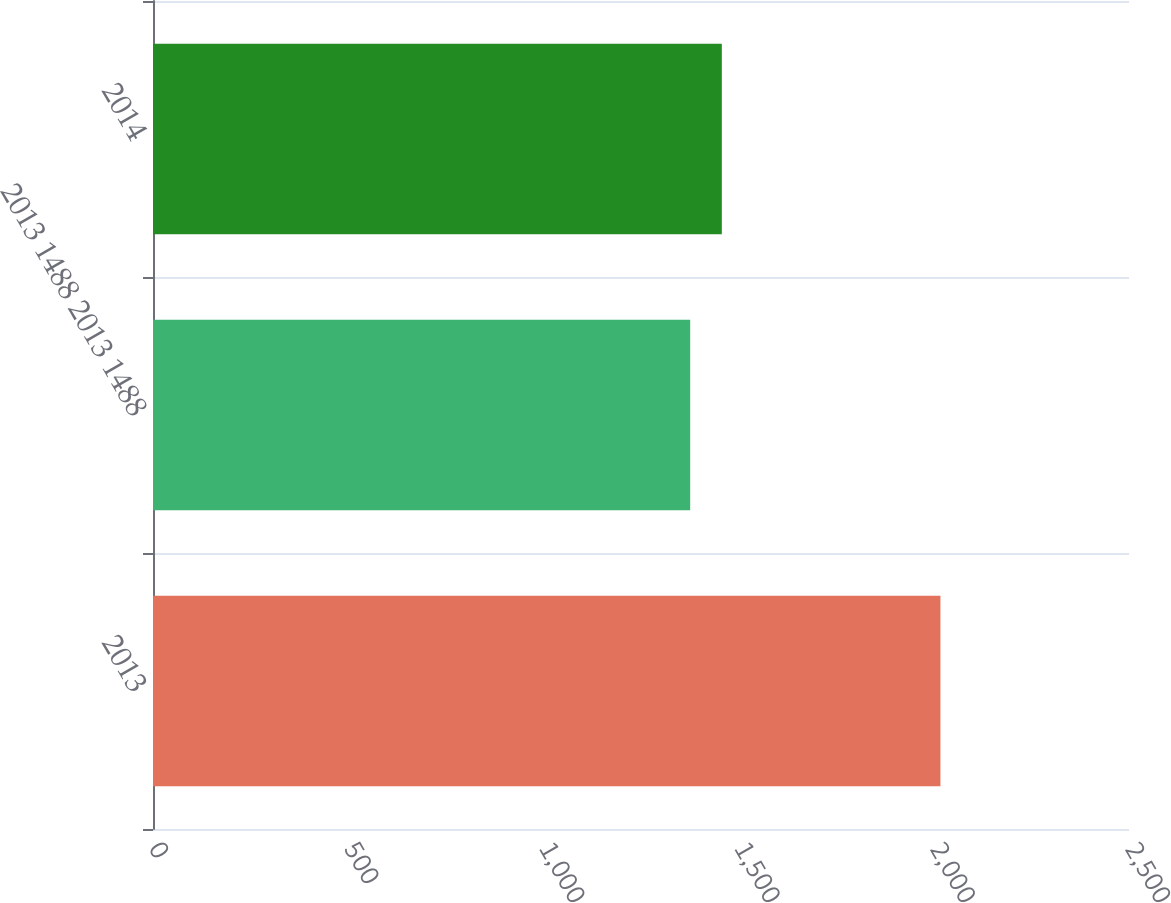Convert chart. <chart><loc_0><loc_0><loc_500><loc_500><bar_chart><fcel>2013<fcel>2013 1488 2013 1488<fcel>2014<nl><fcel>2017<fcel>1376<fcel>1457<nl></chart> 